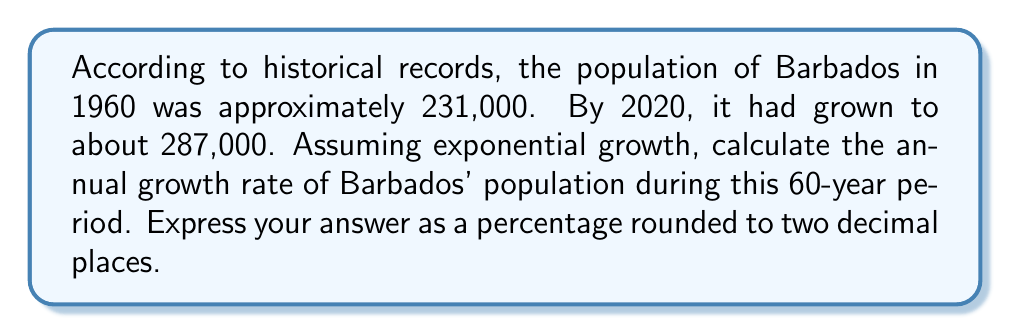Could you help me with this problem? Let's approach this step-by-step using the exponential growth formula:

1) The exponential growth formula is:
   $$A = P(1 + r)^t$$
   Where:
   $A$ = Final amount
   $P$ = Initial amount
   $r$ = Annual growth rate (in decimal form)
   $t$ = Time in years

2) We know:
   $P = 231,000$ (population in 1960)
   $A = 287,000$ (population in 2020)
   $t = 60$ years

3) Substituting these values into the formula:
   $$287,000 = 231,000(1 + r)^{60}$$

4) Divide both sides by 231,000:
   $$\frac{287,000}{231,000} = (1 + r)^{60}$$

5) Simplify:
   $$1.2424 = (1 + r)^{60}$$

6) Take the 60th root of both sides:
   $$\sqrt[60]{1.2424} = 1 + r$$

7) Subtract 1 from both sides:
   $$\sqrt[60]{1.2424} - 1 = r$$

8) Calculate:
   $$r \approx 0.003628$$

9) Convert to a percentage:
   $$0.003628 \times 100 = 0.3628\%$$

10) Round to two decimal places:
    $$0.36\%$$
Answer: 0.36% 